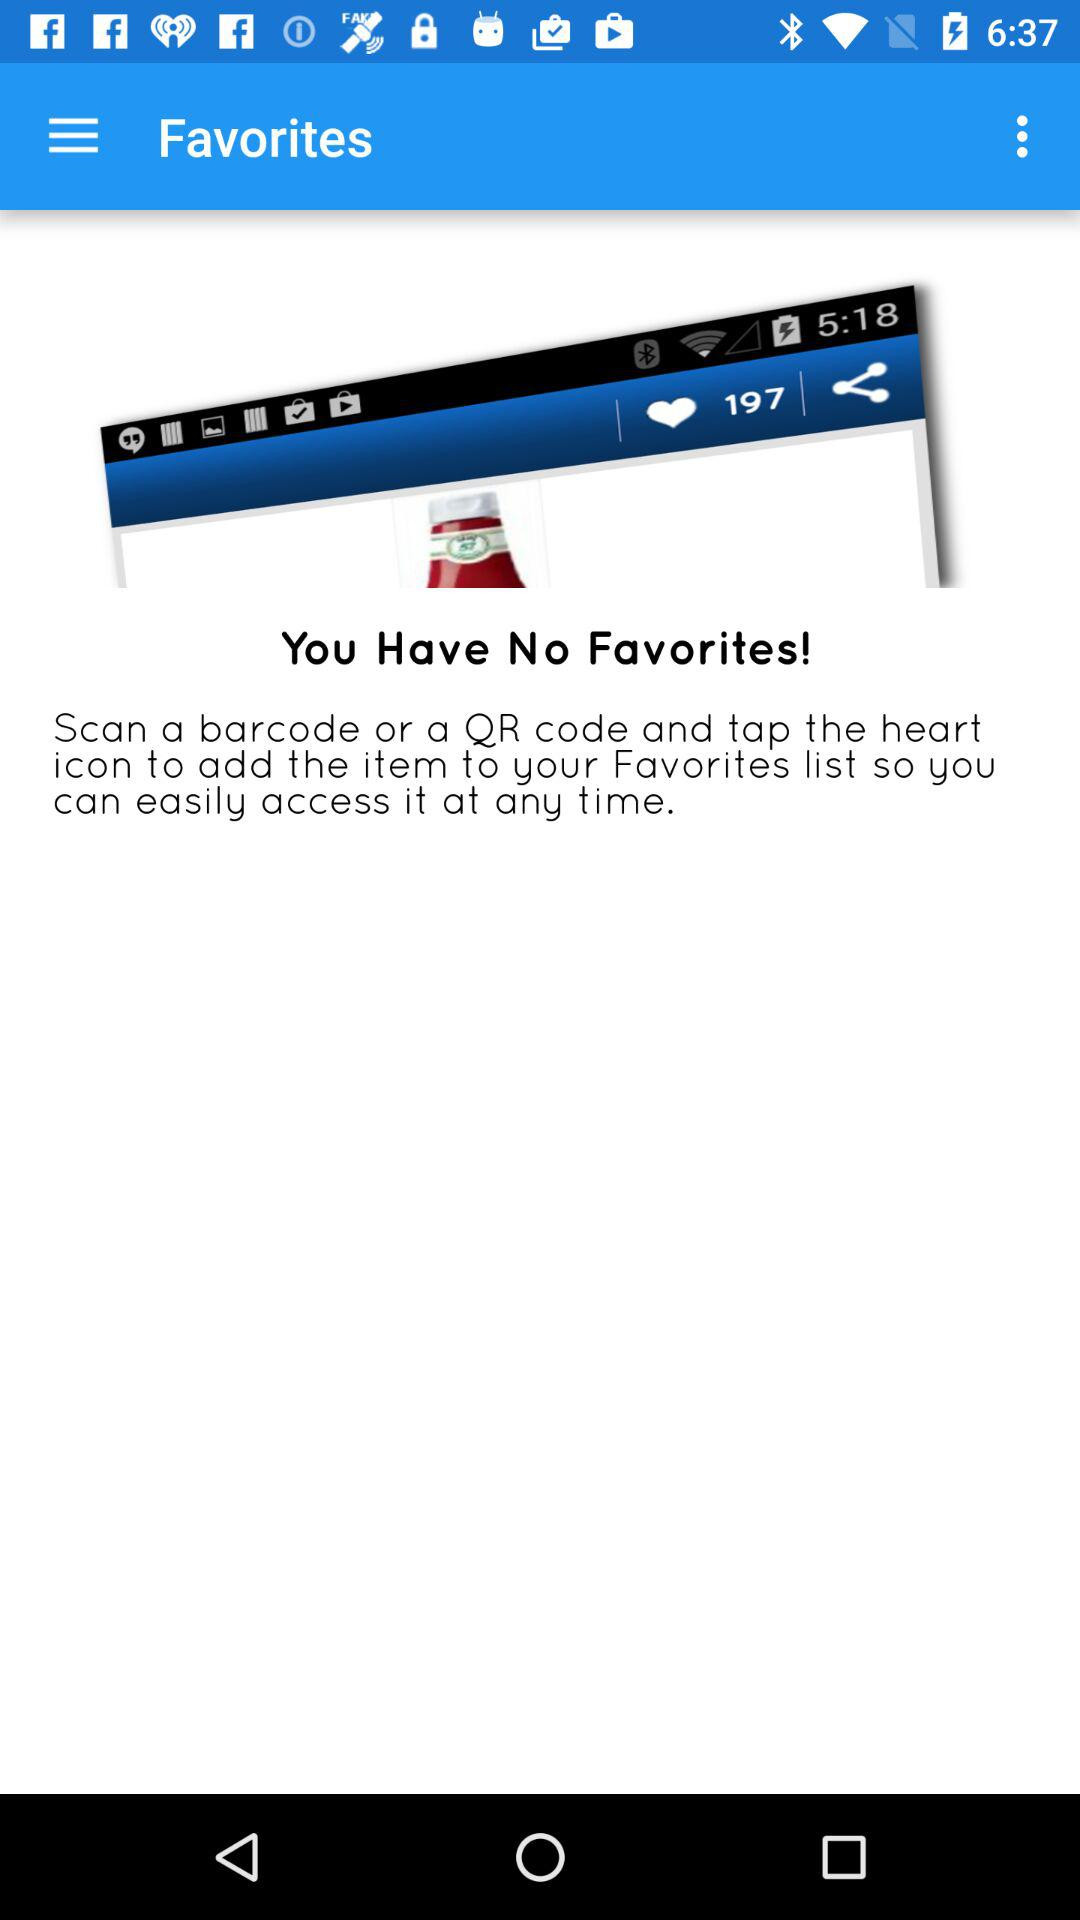How many favorites are shown here? There is no favorite. 